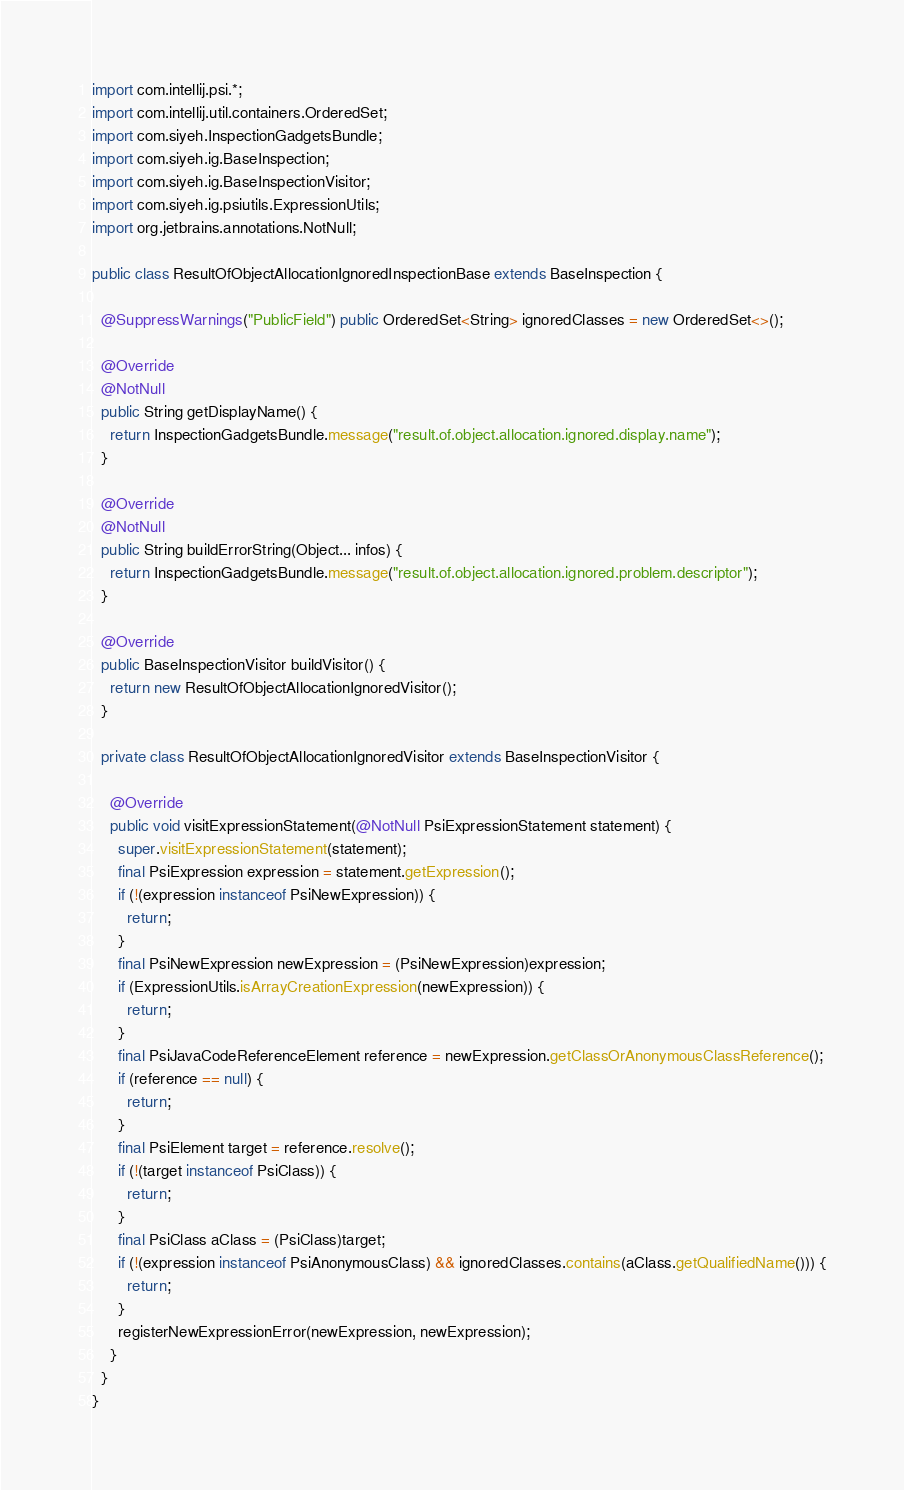Convert code to text. <code><loc_0><loc_0><loc_500><loc_500><_Java_>import com.intellij.psi.*;
import com.intellij.util.containers.OrderedSet;
import com.siyeh.InspectionGadgetsBundle;
import com.siyeh.ig.BaseInspection;
import com.siyeh.ig.BaseInspectionVisitor;
import com.siyeh.ig.psiutils.ExpressionUtils;
import org.jetbrains.annotations.NotNull;

public class ResultOfObjectAllocationIgnoredInspectionBase extends BaseInspection {

  @SuppressWarnings("PublicField") public OrderedSet<String> ignoredClasses = new OrderedSet<>();

  @Override
  @NotNull
  public String getDisplayName() {
    return InspectionGadgetsBundle.message("result.of.object.allocation.ignored.display.name");
  }

  @Override
  @NotNull
  public String buildErrorString(Object... infos) {
    return InspectionGadgetsBundle.message("result.of.object.allocation.ignored.problem.descriptor");
  }

  @Override
  public BaseInspectionVisitor buildVisitor() {
    return new ResultOfObjectAllocationIgnoredVisitor();
  }

  private class ResultOfObjectAllocationIgnoredVisitor extends BaseInspectionVisitor {

    @Override
    public void visitExpressionStatement(@NotNull PsiExpressionStatement statement) {
      super.visitExpressionStatement(statement);
      final PsiExpression expression = statement.getExpression();
      if (!(expression instanceof PsiNewExpression)) {
        return;
      }
      final PsiNewExpression newExpression = (PsiNewExpression)expression;
      if (ExpressionUtils.isArrayCreationExpression(newExpression)) {
        return;
      }
      final PsiJavaCodeReferenceElement reference = newExpression.getClassOrAnonymousClassReference();
      if (reference == null) {
        return;
      }
      final PsiElement target = reference.resolve();
      if (!(target instanceof PsiClass)) {
        return;
      }
      final PsiClass aClass = (PsiClass)target;
      if (!(expression instanceof PsiAnonymousClass) && ignoredClasses.contains(aClass.getQualifiedName())) {
        return;
      }
      registerNewExpressionError(newExpression, newExpression);
    }
  }
}</code> 